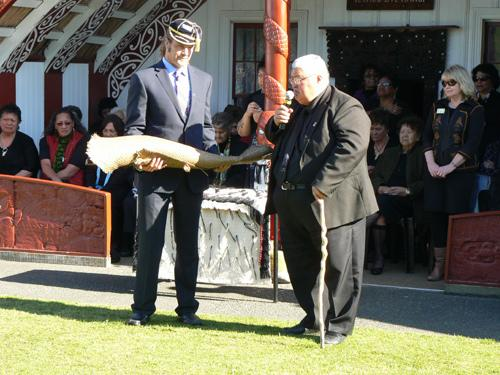What is the thin object the man holding the microphone is using to prop up called? cane 